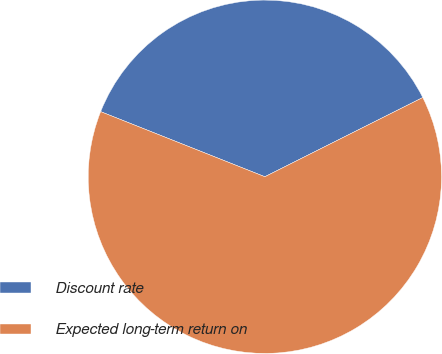Convert chart. <chart><loc_0><loc_0><loc_500><loc_500><pie_chart><fcel>Discount rate<fcel>Expected long-term return on<nl><fcel>36.59%<fcel>63.41%<nl></chart> 